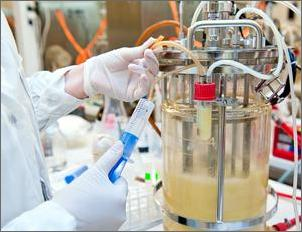What considerations should be taken into account when setting up an experiment like Emilia's? When setting up an experiment like Emilia's, several considerations are crucial. These include ensuring sterility to prevent contamination, calibrating equipment to enable precise control of environmental conditions such as temperature and pH, and selecting appropriate biometric or chemical assays to accurately measure production levels of the target product like insulin. Additionally, replication of the experiments is important to ensure the reliability and reproducibility of the results. 